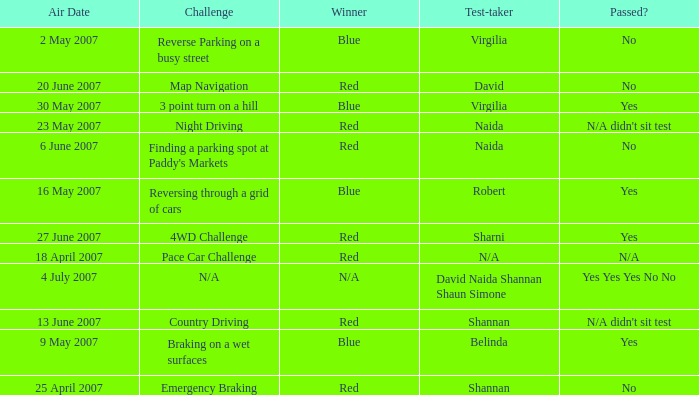What is the result for passing in the country driving challenge? N/A didn't sit test. 